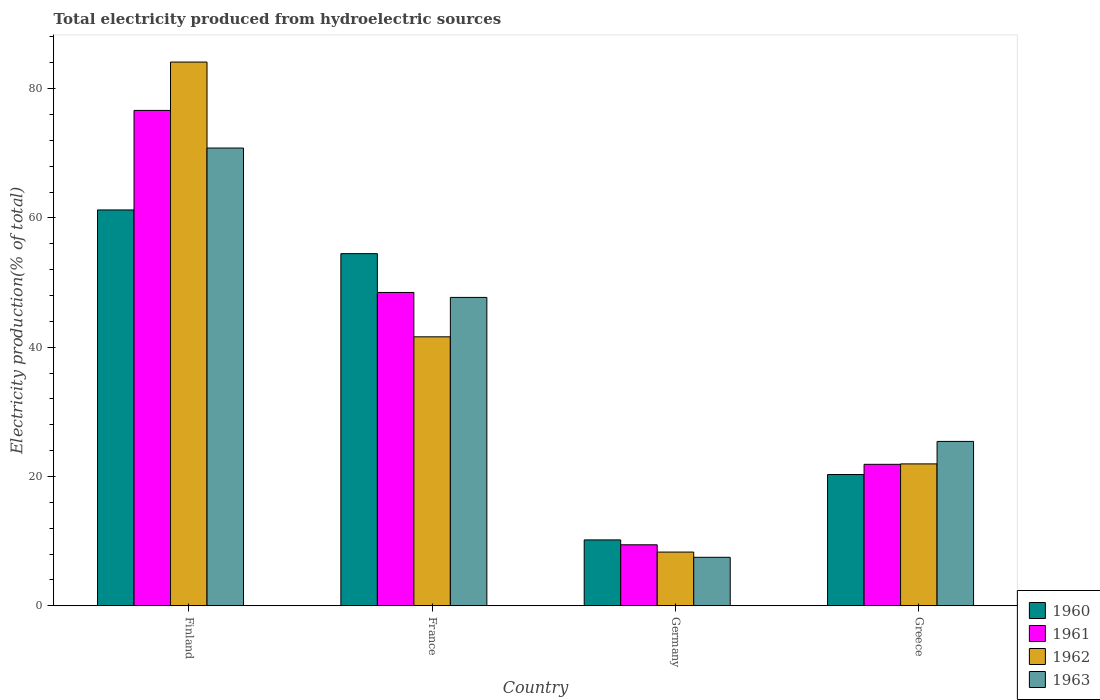How many groups of bars are there?
Make the answer very short. 4. In how many cases, is the number of bars for a given country not equal to the number of legend labels?
Give a very brief answer. 0. What is the total electricity produced in 1963 in Germany?
Your answer should be very brief. 7.5. Across all countries, what is the maximum total electricity produced in 1960?
Give a very brief answer. 61.23. Across all countries, what is the minimum total electricity produced in 1960?
Your answer should be very brief. 10.19. In which country was the total electricity produced in 1960 minimum?
Give a very brief answer. Germany. What is the total total electricity produced in 1963 in the graph?
Offer a terse response. 151.44. What is the difference between the total electricity produced in 1960 in Finland and that in Germany?
Give a very brief answer. 51.04. What is the difference between the total electricity produced in 1961 in Germany and the total electricity produced in 1963 in Greece?
Offer a very short reply. -15.99. What is the average total electricity produced in 1962 per country?
Provide a succinct answer. 38.99. What is the difference between the total electricity produced of/in 1962 and total electricity produced of/in 1960 in Greece?
Provide a succinct answer. 1.64. What is the ratio of the total electricity produced in 1960 in Finland to that in Germany?
Keep it short and to the point. 6.01. Is the total electricity produced in 1960 in Finland less than that in France?
Ensure brevity in your answer.  No. What is the difference between the highest and the second highest total electricity produced in 1962?
Offer a terse response. -42.5. What is the difference between the highest and the lowest total electricity produced in 1961?
Your answer should be very brief. 67.19. Is the sum of the total electricity produced in 1961 in Germany and Greece greater than the maximum total electricity produced in 1963 across all countries?
Your answer should be very brief. No. Is it the case that in every country, the sum of the total electricity produced in 1960 and total electricity produced in 1963 is greater than the sum of total electricity produced in 1962 and total electricity produced in 1961?
Your response must be concise. No. What does the 1st bar from the left in Finland represents?
Your answer should be very brief. 1960. Is it the case that in every country, the sum of the total electricity produced in 1962 and total electricity produced in 1961 is greater than the total electricity produced in 1963?
Provide a succinct answer. Yes. How many bars are there?
Your response must be concise. 16. Are all the bars in the graph horizontal?
Keep it short and to the point. No. What is the difference between two consecutive major ticks on the Y-axis?
Keep it short and to the point. 20. Are the values on the major ticks of Y-axis written in scientific E-notation?
Provide a short and direct response. No. Does the graph contain any zero values?
Give a very brief answer. No. Where does the legend appear in the graph?
Keep it short and to the point. Bottom right. How many legend labels are there?
Provide a short and direct response. 4. What is the title of the graph?
Provide a short and direct response. Total electricity produced from hydroelectric sources. What is the label or title of the Y-axis?
Provide a succinct answer. Electricity production(% of total). What is the Electricity production(% of total) of 1960 in Finland?
Your answer should be very brief. 61.23. What is the Electricity production(% of total) of 1961 in Finland?
Keep it short and to the point. 76.63. What is the Electricity production(% of total) of 1962 in Finland?
Offer a very short reply. 84.11. What is the Electricity production(% of total) in 1963 in Finland?
Offer a very short reply. 70.81. What is the Electricity production(% of total) of 1960 in France?
Keep it short and to the point. 54.47. What is the Electricity production(% of total) in 1961 in France?
Keep it short and to the point. 48.47. What is the Electricity production(% of total) of 1962 in France?
Give a very brief answer. 41.61. What is the Electricity production(% of total) in 1963 in France?
Give a very brief answer. 47.7. What is the Electricity production(% of total) in 1960 in Germany?
Provide a short and direct response. 10.19. What is the Electricity production(% of total) of 1961 in Germany?
Ensure brevity in your answer.  9.44. What is the Electricity production(% of total) in 1962 in Germany?
Provide a succinct answer. 8.31. What is the Electricity production(% of total) in 1963 in Germany?
Offer a very short reply. 7.5. What is the Electricity production(% of total) of 1960 in Greece?
Give a very brief answer. 20.31. What is the Electricity production(% of total) of 1961 in Greece?
Your response must be concise. 21.88. What is the Electricity production(% of total) in 1962 in Greece?
Make the answer very short. 21.95. What is the Electricity production(% of total) in 1963 in Greece?
Your response must be concise. 25.43. Across all countries, what is the maximum Electricity production(% of total) of 1960?
Your answer should be compact. 61.23. Across all countries, what is the maximum Electricity production(% of total) of 1961?
Your response must be concise. 76.63. Across all countries, what is the maximum Electricity production(% of total) of 1962?
Provide a succinct answer. 84.11. Across all countries, what is the maximum Electricity production(% of total) in 1963?
Offer a very short reply. 70.81. Across all countries, what is the minimum Electricity production(% of total) of 1960?
Make the answer very short. 10.19. Across all countries, what is the minimum Electricity production(% of total) of 1961?
Make the answer very short. 9.44. Across all countries, what is the minimum Electricity production(% of total) in 1962?
Offer a very short reply. 8.31. Across all countries, what is the minimum Electricity production(% of total) in 1963?
Give a very brief answer. 7.5. What is the total Electricity production(% of total) in 1960 in the graph?
Provide a short and direct response. 146.2. What is the total Electricity production(% of total) of 1961 in the graph?
Your answer should be compact. 156.42. What is the total Electricity production(% of total) of 1962 in the graph?
Keep it short and to the point. 155.97. What is the total Electricity production(% of total) of 1963 in the graph?
Offer a very short reply. 151.44. What is the difference between the Electricity production(% of total) in 1960 in Finland and that in France?
Provide a short and direct response. 6.76. What is the difference between the Electricity production(% of total) in 1961 in Finland and that in France?
Give a very brief answer. 28.16. What is the difference between the Electricity production(% of total) in 1962 in Finland and that in France?
Make the answer very short. 42.5. What is the difference between the Electricity production(% of total) of 1963 in Finland and that in France?
Provide a short and direct response. 23.11. What is the difference between the Electricity production(% of total) in 1960 in Finland and that in Germany?
Keep it short and to the point. 51.04. What is the difference between the Electricity production(% of total) of 1961 in Finland and that in Germany?
Provide a short and direct response. 67.19. What is the difference between the Electricity production(% of total) of 1962 in Finland and that in Germany?
Your answer should be compact. 75.8. What is the difference between the Electricity production(% of total) of 1963 in Finland and that in Germany?
Your answer should be compact. 63.31. What is the difference between the Electricity production(% of total) of 1960 in Finland and that in Greece?
Make the answer very short. 40.93. What is the difference between the Electricity production(% of total) in 1961 in Finland and that in Greece?
Keep it short and to the point. 54.75. What is the difference between the Electricity production(% of total) in 1962 in Finland and that in Greece?
Your answer should be very brief. 62.16. What is the difference between the Electricity production(% of total) in 1963 in Finland and that in Greece?
Make the answer very short. 45.38. What is the difference between the Electricity production(% of total) in 1960 in France and that in Germany?
Make the answer very short. 44.28. What is the difference between the Electricity production(% of total) of 1961 in France and that in Germany?
Your response must be concise. 39.03. What is the difference between the Electricity production(% of total) of 1962 in France and that in Germany?
Provide a short and direct response. 33.3. What is the difference between the Electricity production(% of total) in 1963 in France and that in Germany?
Your answer should be compact. 40.2. What is the difference between the Electricity production(% of total) in 1960 in France and that in Greece?
Give a very brief answer. 34.17. What is the difference between the Electricity production(% of total) in 1961 in France and that in Greece?
Your response must be concise. 26.58. What is the difference between the Electricity production(% of total) in 1962 in France and that in Greece?
Your answer should be compact. 19.66. What is the difference between the Electricity production(% of total) of 1963 in France and that in Greece?
Provide a succinct answer. 22.27. What is the difference between the Electricity production(% of total) of 1960 in Germany and that in Greece?
Your answer should be compact. -10.11. What is the difference between the Electricity production(% of total) in 1961 in Germany and that in Greece?
Keep it short and to the point. -12.45. What is the difference between the Electricity production(% of total) in 1962 in Germany and that in Greece?
Provide a short and direct response. -13.64. What is the difference between the Electricity production(% of total) of 1963 in Germany and that in Greece?
Make the answer very short. -17.93. What is the difference between the Electricity production(% of total) of 1960 in Finland and the Electricity production(% of total) of 1961 in France?
Offer a very short reply. 12.76. What is the difference between the Electricity production(% of total) of 1960 in Finland and the Electricity production(% of total) of 1962 in France?
Provide a short and direct response. 19.63. What is the difference between the Electricity production(% of total) of 1960 in Finland and the Electricity production(% of total) of 1963 in France?
Your answer should be compact. 13.53. What is the difference between the Electricity production(% of total) of 1961 in Finland and the Electricity production(% of total) of 1962 in France?
Provide a succinct answer. 35.02. What is the difference between the Electricity production(% of total) in 1961 in Finland and the Electricity production(% of total) in 1963 in France?
Your answer should be compact. 28.93. What is the difference between the Electricity production(% of total) in 1962 in Finland and the Electricity production(% of total) in 1963 in France?
Make the answer very short. 36.41. What is the difference between the Electricity production(% of total) of 1960 in Finland and the Electricity production(% of total) of 1961 in Germany?
Offer a very short reply. 51.8. What is the difference between the Electricity production(% of total) of 1960 in Finland and the Electricity production(% of total) of 1962 in Germany?
Provide a succinct answer. 52.92. What is the difference between the Electricity production(% of total) in 1960 in Finland and the Electricity production(% of total) in 1963 in Germany?
Your answer should be compact. 53.73. What is the difference between the Electricity production(% of total) in 1961 in Finland and the Electricity production(% of total) in 1962 in Germany?
Give a very brief answer. 68.32. What is the difference between the Electricity production(% of total) in 1961 in Finland and the Electricity production(% of total) in 1963 in Germany?
Provide a succinct answer. 69.13. What is the difference between the Electricity production(% of total) in 1962 in Finland and the Electricity production(% of total) in 1963 in Germany?
Your response must be concise. 76.61. What is the difference between the Electricity production(% of total) of 1960 in Finland and the Electricity production(% of total) of 1961 in Greece?
Offer a terse response. 39.35. What is the difference between the Electricity production(% of total) in 1960 in Finland and the Electricity production(% of total) in 1962 in Greece?
Your answer should be compact. 39.28. What is the difference between the Electricity production(% of total) of 1960 in Finland and the Electricity production(% of total) of 1963 in Greece?
Provide a succinct answer. 35.8. What is the difference between the Electricity production(% of total) of 1961 in Finland and the Electricity production(% of total) of 1962 in Greece?
Ensure brevity in your answer.  54.68. What is the difference between the Electricity production(% of total) of 1961 in Finland and the Electricity production(% of total) of 1963 in Greece?
Give a very brief answer. 51.2. What is the difference between the Electricity production(% of total) in 1962 in Finland and the Electricity production(% of total) in 1963 in Greece?
Your answer should be compact. 58.68. What is the difference between the Electricity production(% of total) of 1960 in France and the Electricity production(% of total) of 1961 in Germany?
Give a very brief answer. 45.04. What is the difference between the Electricity production(% of total) in 1960 in France and the Electricity production(% of total) in 1962 in Germany?
Your response must be concise. 46.16. What is the difference between the Electricity production(% of total) in 1960 in France and the Electricity production(% of total) in 1963 in Germany?
Provide a succinct answer. 46.97. What is the difference between the Electricity production(% of total) of 1961 in France and the Electricity production(% of total) of 1962 in Germany?
Keep it short and to the point. 40.16. What is the difference between the Electricity production(% of total) of 1961 in France and the Electricity production(% of total) of 1963 in Germany?
Your answer should be very brief. 40.97. What is the difference between the Electricity production(% of total) in 1962 in France and the Electricity production(% of total) in 1963 in Germany?
Your answer should be compact. 34.11. What is the difference between the Electricity production(% of total) in 1960 in France and the Electricity production(% of total) in 1961 in Greece?
Offer a terse response. 32.59. What is the difference between the Electricity production(% of total) of 1960 in France and the Electricity production(% of total) of 1962 in Greece?
Your answer should be very brief. 32.52. What is the difference between the Electricity production(% of total) of 1960 in France and the Electricity production(% of total) of 1963 in Greece?
Provide a succinct answer. 29.05. What is the difference between the Electricity production(% of total) of 1961 in France and the Electricity production(% of total) of 1962 in Greece?
Provide a succinct answer. 26.52. What is the difference between the Electricity production(% of total) of 1961 in France and the Electricity production(% of total) of 1963 in Greece?
Offer a very short reply. 23.04. What is the difference between the Electricity production(% of total) of 1962 in France and the Electricity production(% of total) of 1963 in Greece?
Make the answer very short. 16.18. What is the difference between the Electricity production(% of total) in 1960 in Germany and the Electricity production(% of total) in 1961 in Greece?
Your answer should be compact. -11.69. What is the difference between the Electricity production(% of total) of 1960 in Germany and the Electricity production(% of total) of 1962 in Greece?
Your response must be concise. -11.76. What is the difference between the Electricity production(% of total) of 1960 in Germany and the Electricity production(% of total) of 1963 in Greece?
Provide a succinct answer. -15.24. What is the difference between the Electricity production(% of total) in 1961 in Germany and the Electricity production(% of total) in 1962 in Greece?
Keep it short and to the point. -12.51. What is the difference between the Electricity production(% of total) of 1961 in Germany and the Electricity production(% of total) of 1963 in Greece?
Your answer should be very brief. -15.99. What is the difference between the Electricity production(% of total) in 1962 in Germany and the Electricity production(% of total) in 1963 in Greece?
Give a very brief answer. -17.12. What is the average Electricity production(% of total) of 1960 per country?
Give a very brief answer. 36.55. What is the average Electricity production(% of total) in 1961 per country?
Your answer should be very brief. 39.1. What is the average Electricity production(% of total) of 1962 per country?
Provide a succinct answer. 38.99. What is the average Electricity production(% of total) of 1963 per country?
Offer a terse response. 37.86. What is the difference between the Electricity production(% of total) of 1960 and Electricity production(% of total) of 1961 in Finland?
Give a very brief answer. -15.4. What is the difference between the Electricity production(% of total) in 1960 and Electricity production(% of total) in 1962 in Finland?
Keep it short and to the point. -22.88. What is the difference between the Electricity production(% of total) of 1960 and Electricity production(% of total) of 1963 in Finland?
Keep it short and to the point. -9.58. What is the difference between the Electricity production(% of total) in 1961 and Electricity production(% of total) in 1962 in Finland?
Provide a succinct answer. -7.48. What is the difference between the Electricity production(% of total) of 1961 and Electricity production(% of total) of 1963 in Finland?
Your response must be concise. 5.82. What is the difference between the Electricity production(% of total) in 1962 and Electricity production(% of total) in 1963 in Finland?
Provide a succinct answer. 13.3. What is the difference between the Electricity production(% of total) in 1960 and Electricity production(% of total) in 1961 in France?
Ensure brevity in your answer.  6.01. What is the difference between the Electricity production(% of total) in 1960 and Electricity production(% of total) in 1962 in France?
Provide a short and direct response. 12.87. What is the difference between the Electricity production(% of total) in 1960 and Electricity production(% of total) in 1963 in France?
Give a very brief answer. 6.77. What is the difference between the Electricity production(% of total) in 1961 and Electricity production(% of total) in 1962 in France?
Your response must be concise. 6.86. What is the difference between the Electricity production(% of total) of 1961 and Electricity production(% of total) of 1963 in France?
Offer a very short reply. 0.77. What is the difference between the Electricity production(% of total) in 1962 and Electricity production(% of total) in 1963 in France?
Make the answer very short. -6.1. What is the difference between the Electricity production(% of total) in 1960 and Electricity production(% of total) in 1961 in Germany?
Keep it short and to the point. 0.76. What is the difference between the Electricity production(% of total) in 1960 and Electricity production(% of total) in 1962 in Germany?
Keep it short and to the point. 1.88. What is the difference between the Electricity production(% of total) in 1960 and Electricity production(% of total) in 1963 in Germany?
Ensure brevity in your answer.  2.69. What is the difference between the Electricity production(% of total) of 1961 and Electricity production(% of total) of 1962 in Germany?
Keep it short and to the point. 1.13. What is the difference between the Electricity production(% of total) in 1961 and Electricity production(% of total) in 1963 in Germany?
Ensure brevity in your answer.  1.94. What is the difference between the Electricity production(% of total) in 1962 and Electricity production(% of total) in 1963 in Germany?
Provide a short and direct response. 0.81. What is the difference between the Electricity production(% of total) in 1960 and Electricity production(% of total) in 1961 in Greece?
Offer a very short reply. -1.58. What is the difference between the Electricity production(% of total) of 1960 and Electricity production(% of total) of 1962 in Greece?
Offer a terse response. -1.64. What is the difference between the Electricity production(% of total) in 1960 and Electricity production(% of total) in 1963 in Greece?
Keep it short and to the point. -5.12. What is the difference between the Electricity production(% of total) in 1961 and Electricity production(% of total) in 1962 in Greece?
Keep it short and to the point. -0.07. What is the difference between the Electricity production(% of total) in 1961 and Electricity production(% of total) in 1963 in Greece?
Keep it short and to the point. -3.54. What is the difference between the Electricity production(% of total) of 1962 and Electricity production(% of total) of 1963 in Greece?
Provide a short and direct response. -3.48. What is the ratio of the Electricity production(% of total) in 1960 in Finland to that in France?
Ensure brevity in your answer.  1.12. What is the ratio of the Electricity production(% of total) in 1961 in Finland to that in France?
Give a very brief answer. 1.58. What is the ratio of the Electricity production(% of total) of 1962 in Finland to that in France?
Your response must be concise. 2.02. What is the ratio of the Electricity production(% of total) in 1963 in Finland to that in France?
Ensure brevity in your answer.  1.48. What is the ratio of the Electricity production(% of total) of 1960 in Finland to that in Germany?
Your answer should be very brief. 6.01. What is the ratio of the Electricity production(% of total) in 1961 in Finland to that in Germany?
Give a very brief answer. 8.12. What is the ratio of the Electricity production(% of total) in 1962 in Finland to that in Germany?
Offer a very short reply. 10.12. What is the ratio of the Electricity production(% of total) of 1963 in Finland to that in Germany?
Your answer should be very brief. 9.44. What is the ratio of the Electricity production(% of total) of 1960 in Finland to that in Greece?
Provide a succinct answer. 3.02. What is the ratio of the Electricity production(% of total) of 1961 in Finland to that in Greece?
Keep it short and to the point. 3.5. What is the ratio of the Electricity production(% of total) of 1962 in Finland to that in Greece?
Make the answer very short. 3.83. What is the ratio of the Electricity production(% of total) in 1963 in Finland to that in Greece?
Keep it short and to the point. 2.78. What is the ratio of the Electricity production(% of total) in 1960 in France to that in Germany?
Provide a short and direct response. 5.34. What is the ratio of the Electricity production(% of total) of 1961 in France to that in Germany?
Provide a short and direct response. 5.14. What is the ratio of the Electricity production(% of total) of 1962 in France to that in Germany?
Your answer should be very brief. 5.01. What is the ratio of the Electricity production(% of total) in 1963 in France to that in Germany?
Your answer should be very brief. 6.36. What is the ratio of the Electricity production(% of total) of 1960 in France to that in Greece?
Make the answer very short. 2.68. What is the ratio of the Electricity production(% of total) of 1961 in France to that in Greece?
Ensure brevity in your answer.  2.21. What is the ratio of the Electricity production(% of total) of 1962 in France to that in Greece?
Provide a short and direct response. 1.9. What is the ratio of the Electricity production(% of total) in 1963 in France to that in Greece?
Your answer should be compact. 1.88. What is the ratio of the Electricity production(% of total) of 1960 in Germany to that in Greece?
Your response must be concise. 0.5. What is the ratio of the Electricity production(% of total) in 1961 in Germany to that in Greece?
Your answer should be very brief. 0.43. What is the ratio of the Electricity production(% of total) in 1962 in Germany to that in Greece?
Make the answer very short. 0.38. What is the ratio of the Electricity production(% of total) of 1963 in Germany to that in Greece?
Provide a short and direct response. 0.29. What is the difference between the highest and the second highest Electricity production(% of total) in 1960?
Offer a terse response. 6.76. What is the difference between the highest and the second highest Electricity production(% of total) in 1961?
Provide a succinct answer. 28.16. What is the difference between the highest and the second highest Electricity production(% of total) of 1962?
Offer a terse response. 42.5. What is the difference between the highest and the second highest Electricity production(% of total) of 1963?
Make the answer very short. 23.11. What is the difference between the highest and the lowest Electricity production(% of total) of 1960?
Ensure brevity in your answer.  51.04. What is the difference between the highest and the lowest Electricity production(% of total) in 1961?
Your answer should be very brief. 67.19. What is the difference between the highest and the lowest Electricity production(% of total) of 1962?
Offer a very short reply. 75.8. What is the difference between the highest and the lowest Electricity production(% of total) in 1963?
Provide a short and direct response. 63.31. 